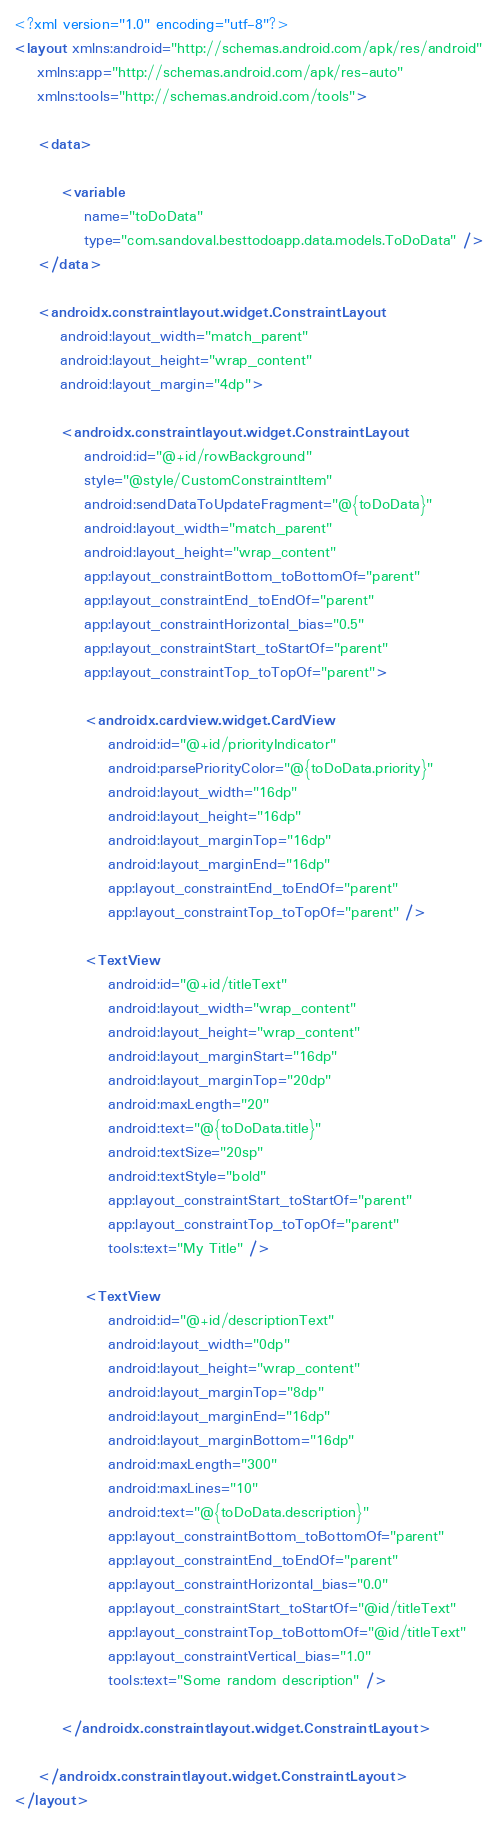Convert code to text. <code><loc_0><loc_0><loc_500><loc_500><_XML_><?xml version="1.0" encoding="utf-8"?>
<layout xmlns:android="http://schemas.android.com/apk/res/android"
    xmlns:app="http://schemas.android.com/apk/res-auto"
    xmlns:tools="http://schemas.android.com/tools">

    <data>

        <variable
            name="toDoData"
            type="com.sandoval.besttodoapp.data.models.ToDoData" />
    </data>

    <androidx.constraintlayout.widget.ConstraintLayout
        android:layout_width="match_parent"
        android:layout_height="wrap_content"
        android:layout_margin="4dp">

        <androidx.constraintlayout.widget.ConstraintLayout
            android:id="@+id/rowBackground"
            style="@style/CustomConstraintItem"
            android:sendDataToUpdateFragment="@{toDoData}"
            android:layout_width="match_parent"
            android:layout_height="wrap_content"
            app:layout_constraintBottom_toBottomOf="parent"
            app:layout_constraintEnd_toEndOf="parent"
            app:layout_constraintHorizontal_bias="0.5"
            app:layout_constraintStart_toStartOf="parent"
            app:layout_constraintTop_toTopOf="parent">

            <androidx.cardview.widget.CardView
                android:id="@+id/priorityIndicator"
                android:parsePriorityColor="@{toDoData.priority}"
                android:layout_width="16dp"
                android:layout_height="16dp"
                android:layout_marginTop="16dp"
                android:layout_marginEnd="16dp"
                app:layout_constraintEnd_toEndOf="parent"
                app:layout_constraintTop_toTopOf="parent" />

            <TextView
                android:id="@+id/titleText"
                android:layout_width="wrap_content"
                android:layout_height="wrap_content"
                android:layout_marginStart="16dp"
                android:layout_marginTop="20dp"
                android:maxLength="20"
                android:text="@{toDoData.title}"
                android:textSize="20sp"
                android:textStyle="bold"
                app:layout_constraintStart_toStartOf="parent"
                app:layout_constraintTop_toTopOf="parent"
                tools:text="My Title" />

            <TextView
                android:id="@+id/descriptionText"
                android:layout_width="0dp"
                android:layout_height="wrap_content"
                android:layout_marginTop="8dp"
                android:layout_marginEnd="16dp"
                android:layout_marginBottom="16dp"
                android:maxLength="300"
                android:maxLines="10"
                android:text="@{toDoData.description}"
                app:layout_constraintBottom_toBottomOf="parent"
                app:layout_constraintEnd_toEndOf="parent"
                app:layout_constraintHorizontal_bias="0.0"
                app:layout_constraintStart_toStartOf="@id/titleText"
                app:layout_constraintTop_toBottomOf="@id/titleText"
                app:layout_constraintVertical_bias="1.0"
                tools:text="Some random description" />

        </androidx.constraintlayout.widget.ConstraintLayout>

    </androidx.constraintlayout.widget.ConstraintLayout>
</layout></code> 